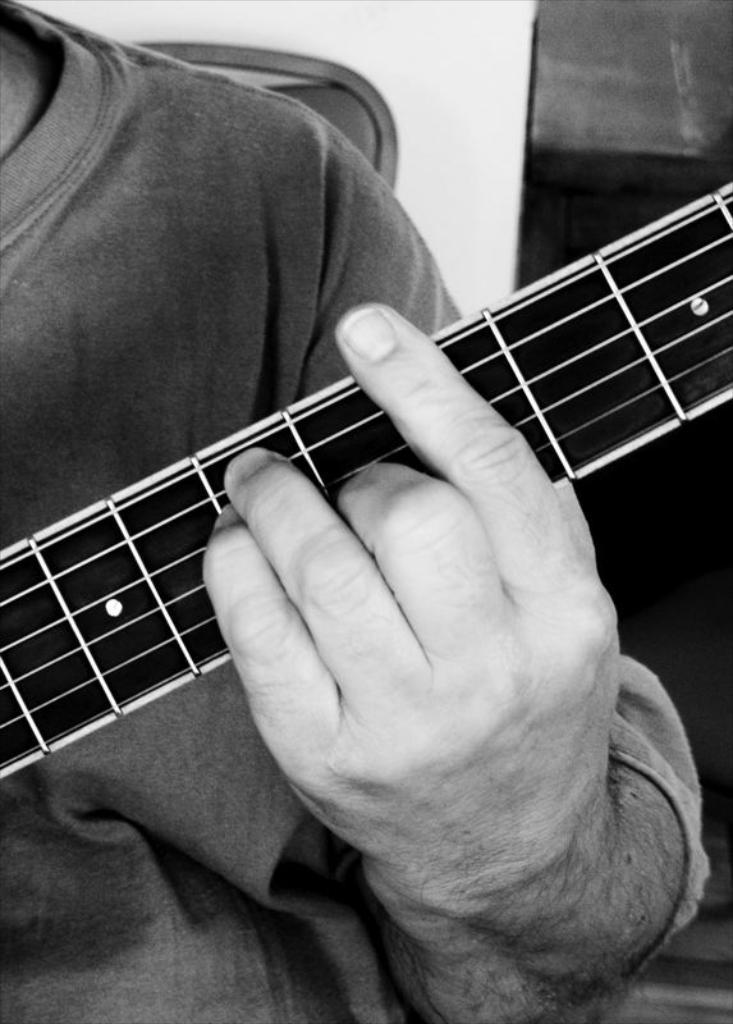Could you give a brief overview of what you see in this image? A black and white picture. This man is playing a musical instrument. 